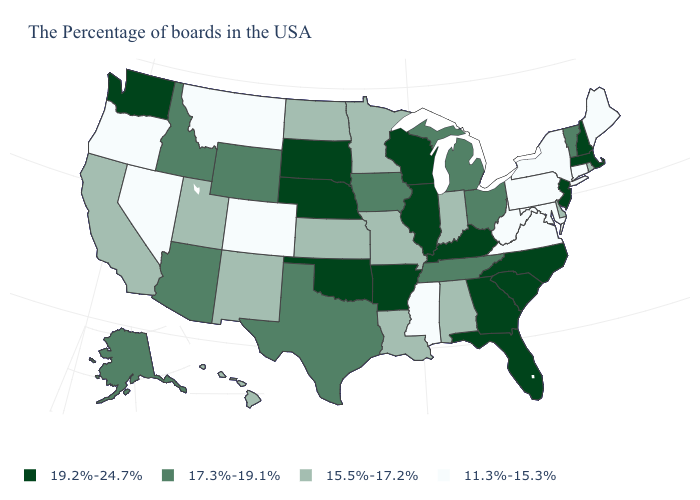How many symbols are there in the legend?
Quick response, please. 4. What is the value of Washington?
Short answer required. 19.2%-24.7%. Which states have the highest value in the USA?
Give a very brief answer. Massachusetts, New Hampshire, New Jersey, North Carolina, South Carolina, Florida, Georgia, Kentucky, Wisconsin, Illinois, Arkansas, Nebraska, Oklahoma, South Dakota, Washington. Does Arizona have the lowest value in the West?
Short answer required. No. What is the highest value in the West ?
Answer briefly. 19.2%-24.7%. Among the states that border Nevada , which have the highest value?
Give a very brief answer. Arizona, Idaho. What is the highest value in the USA?
Give a very brief answer. 19.2%-24.7%. Does Nebraska have the highest value in the MidWest?
Answer briefly. Yes. Does Iowa have the same value as Ohio?
Quick response, please. Yes. What is the value of Alabama?
Write a very short answer. 15.5%-17.2%. Does the first symbol in the legend represent the smallest category?
Answer briefly. No. Name the states that have a value in the range 15.5%-17.2%?
Quick response, please. Rhode Island, Delaware, Indiana, Alabama, Louisiana, Missouri, Minnesota, Kansas, North Dakota, New Mexico, Utah, California, Hawaii. What is the lowest value in the USA?
Concise answer only. 11.3%-15.3%. What is the value of Montana?
Concise answer only. 11.3%-15.3%. 